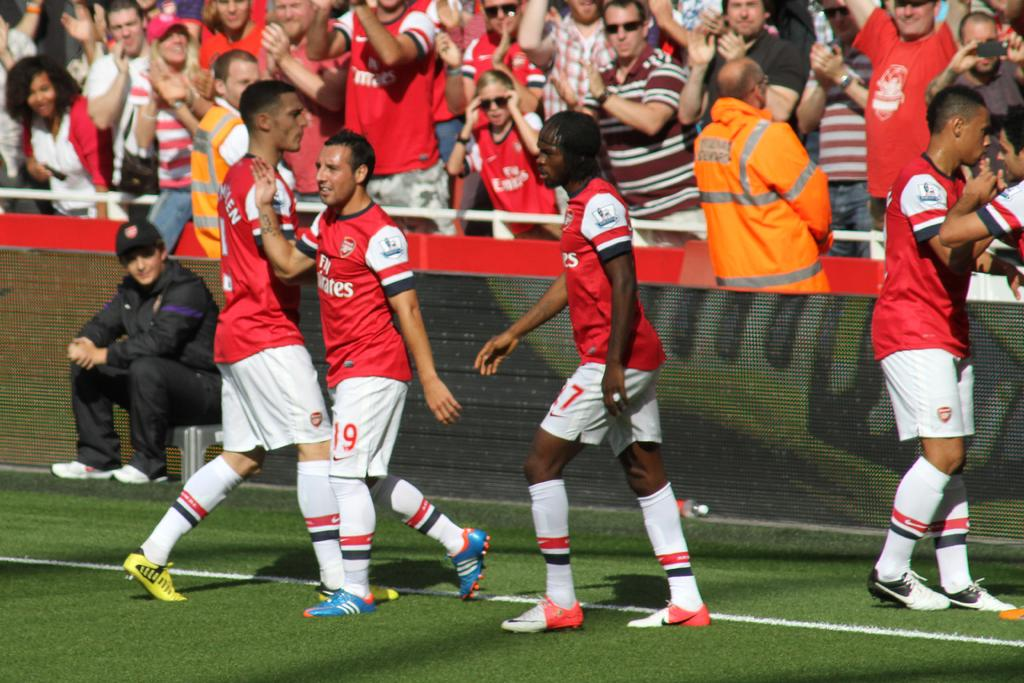<image>
Create a compact narrative representing the image presented. a soccer team with one of the players wearing the number 19 